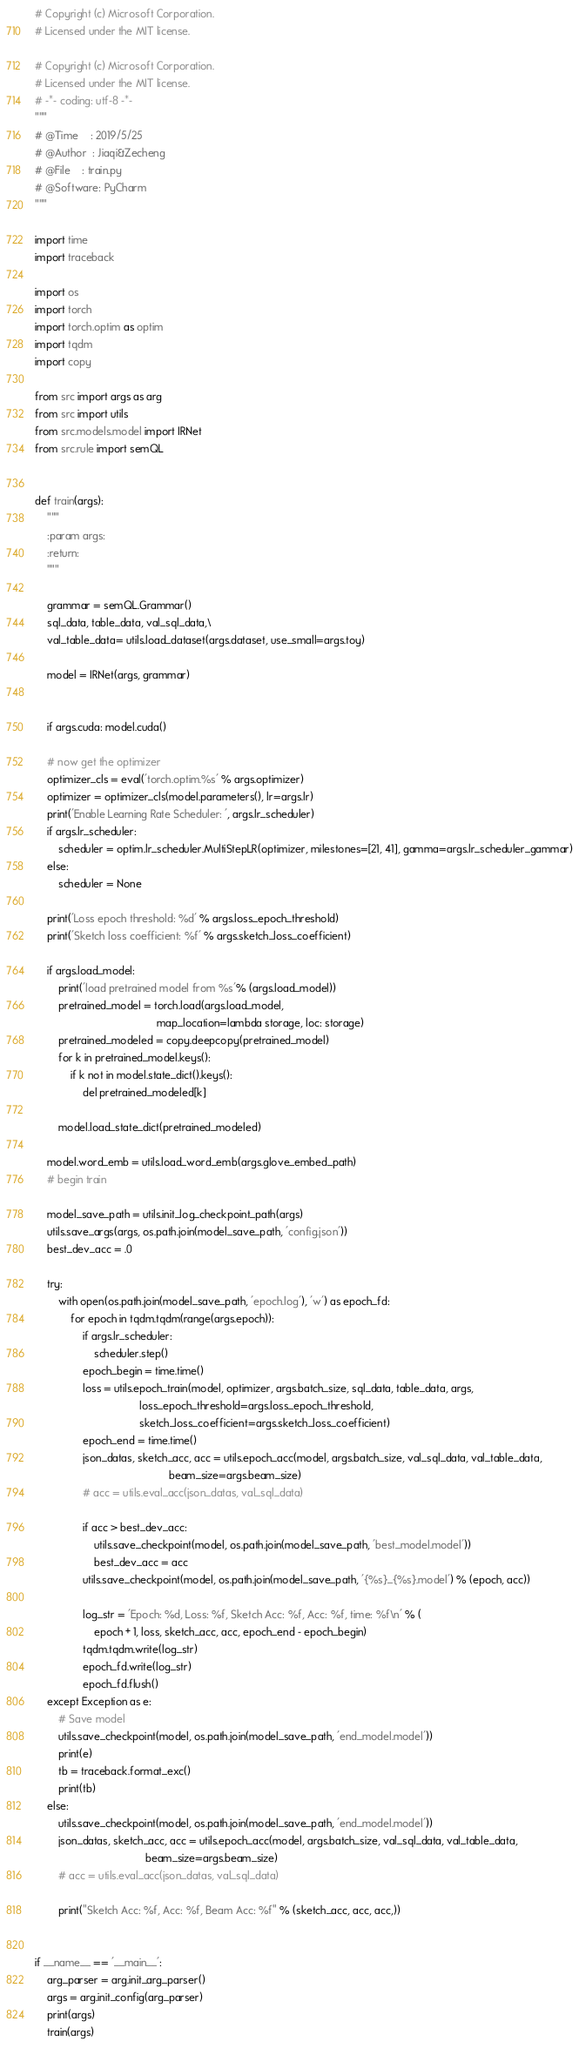Convert code to text. <code><loc_0><loc_0><loc_500><loc_500><_Python_># Copyright (c) Microsoft Corporation.
# Licensed under the MIT license.

# Copyright (c) Microsoft Corporation.
# Licensed under the MIT license.
# -*- coding: utf-8 -*-
"""
# @Time    : 2019/5/25
# @Author  : Jiaqi&Zecheng
# @File    : train.py
# @Software: PyCharm
"""

import time
import traceback

import os
import torch
import torch.optim as optim
import tqdm
import copy

from src import args as arg
from src import utils
from src.models.model import IRNet
from src.rule import semQL


def train(args):
    """
    :param args:
    :return:
    """

    grammar = semQL.Grammar()
    sql_data, table_data, val_sql_data,\
    val_table_data= utils.load_dataset(args.dataset, use_small=args.toy)

    model = IRNet(args, grammar)


    if args.cuda: model.cuda()

    # now get the optimizer
    optimizer_cls = eval('torch.optim.%s' % args.optimizer)
    optimizer = optimizer_cls(model.parameters(), lr=args.lr)
    print('Enable Learning Rate Scheduler: ', args.lr_scheduler)
    if args.lr_scheduler:
        scheduler = optim.lr_scheduler.MultiStepLR(optimizer, milestones=[21, 41], gamma=args.lr_scheduler_gammar)
    else:
        scheduler = None

    print('Loss epoch threshold: %d' % args.loss_epoch_threshold)
    print('Sketch loss coefficient: %f' % args.sketch_loss_coefficient)

    if args.load_model:
        print('load pretrained model from %s'% (args.load_model))
        pretrained_model = torch.load(args.load_model,
                                         map_location=lambda storage, loc: storage)
        pretrained_modeled = copy.deepcopy(pretrained_model)
        for k in pretrained_model.keys():
            if k not in model.state_dict().keys():
                del pretrained_modeled[k]

        model.load_state_dict(pretrained_modeled)

    model.word_emb = utils.load_word_emb(args.glove_embed_path)
    # begin train

    model_save_path = utils.init_log_checkpoint_path(args)
    utils.save_args(args, os.path.join(model_save_path, 'config.json'))
    best_dev_acc = .0

    try:
        with open(os.path.join(model_save_path, 'epoch.log'), 'w') as epoch_fd:
            for epoch in tqdm.tqdm(range(args.epoch)):
                if args.lr_scheduler:
                    scheduler.step()
                epoch_begin = time.time()
                loss = utils.epoch_train(model, optimizer, args.batch_size, sql_data, table_data, args,
                                   loss_epoch_threshold=args.loss_epoch_threshold,
                                   sketch_loss_coefficient=args.sketch_loss_coefficient)
                epoch_end = time.time()
                json_datas, sketch_acc, acc = utils.epoch_acc(model, args.batch_size, val_sql_data, val_table_data,
                                             beam_size=args.beam_size)
                # acc = utils.eval_acc(json_datas, val_sql_data)

                if acc > best_dev_acc:
                    utils.save_checkpoint(model, os.path.join(model_save_path, 'best_model.model'))
                    best_dev_acc = acc
                utils.save_checkpoint(model, os.path.join(model_save_path, '{%s}_{%s}.model') % (epoch, acc))

                log_str = 'Epoch: %d, Loss: %f, Sketch Acc: %f, Acc: %f, time: %f\n' % (
                    epoch + 1, loss, sketch_acc, acc, epoch_end - epoch_begin)
                tqdm.tqdm.write(log_str)
                epoch_fd.write(log_str)
                epoch_fd.flush()
    except Exception as e:
        # Save model
        utils.save_checkpoint(model, os.path.join(model_save_path, 'end_model.model'))
        print(e)
        tb = traceback.format_exc()
        print(tb)
    else:
        utils.save_checkpoint(model, os.path.join(model_save_path, 'end_model.model'))
        json_datas, sketch_acc, acc = utils.epoch_acc(model, args.batch_size, val_sql_data, val_table_data,
                                     beam_size=args.beam_size)
        # acc = utils.eval_acc(json_datas, val_sql_data)

        print("Sketch Acc: %f, Acc: %f, Beam Acc: %f" % (sketch_acc, acc, acc,))


if __name__ == '__main__':
    arg_parser = arg.init_arg_parser()
    args = arg.init_config(arg_parser)
    print(args)
    train(args)
</code> 